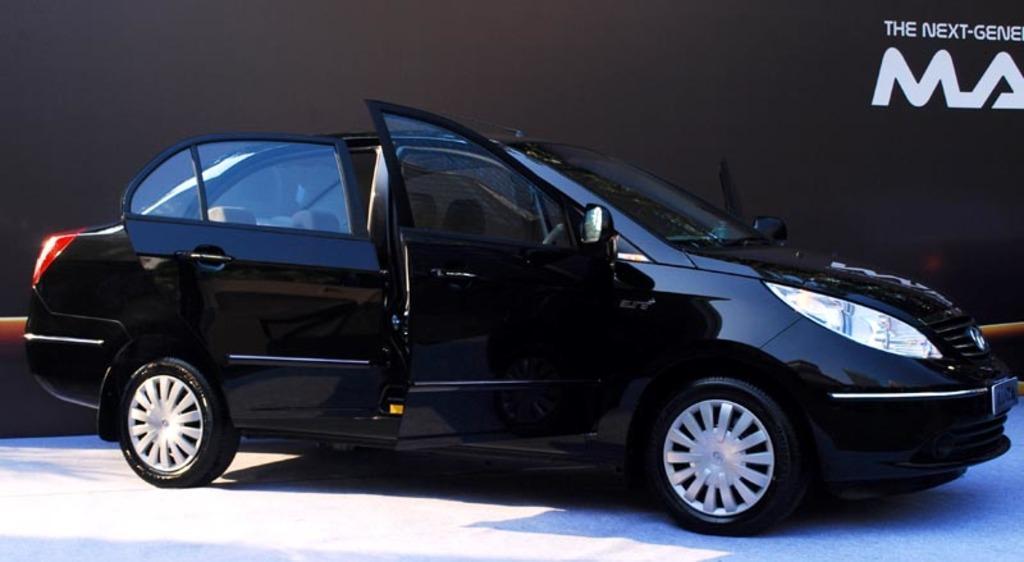Can you describe this image briefly? In the center of the image we can see a car which is in black color. On the right there is a text. 